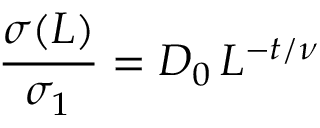Convert formula to latex. <formula><loc_0><loc_0><loc_500><loc_500>\frac { \sigma ( L ) } { \sigma _ { 1 } } = D _ { 0 } \, L ^ { - t / \nu }</formula> 